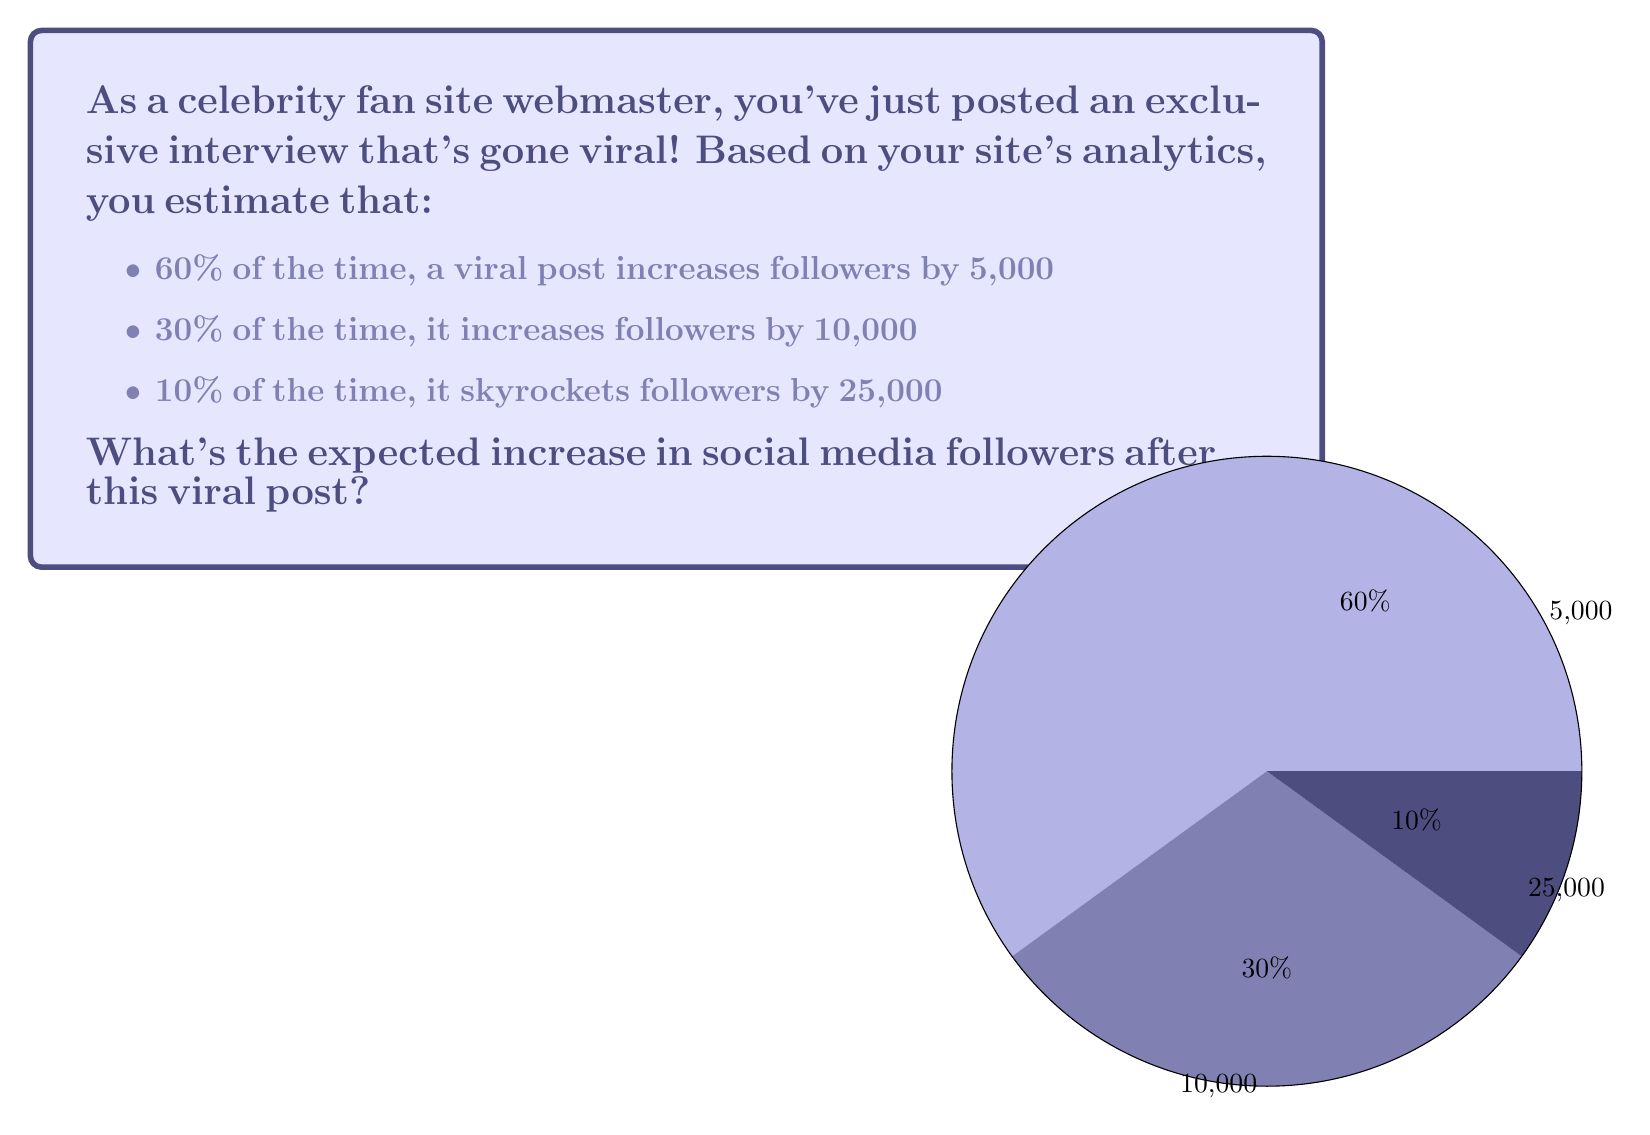Can you solve this math problem? To solve this problem, we need to calculate the expected value using the given probabilities and outcomes. Let's break it down step-by-step:

1) The expected value is calculated by multiplying each possible outcome by its probability and then summing these products.

2) Let's define our events:
   $A$: 5,000 follower increase (60% probability)
   $B$: 10,000 follower increase (30% probability)
   $C$: 25,000 follower increase (10% probability)

3) Now, let's calculate the expected value:

   $$E = P(A) \cdot 5,000 + P(B) \cdot 10,000 + P(C) \cdot 25,000$$

4) Substituting the probabilities:

   $$E = 0.60 \cdot 5,000 + 0.30 \cdot 10,000 + 0.10 \cdot 25,000$$

5) Let's calculate each term:
   $0.60 \cdot 5,000 = 3,000$
   $0.30 \cdot 10,000 = 3,000$
   $0.10 \cdot 25,000 = 2,500$

6) Now, sum up all terms:

   $$E = 3,000 + 3,000 + 2,500 = 8,500$$

Therefore, the expected increase in social media followers after this viral post is 8,500.
Answer: 8,500 followers 